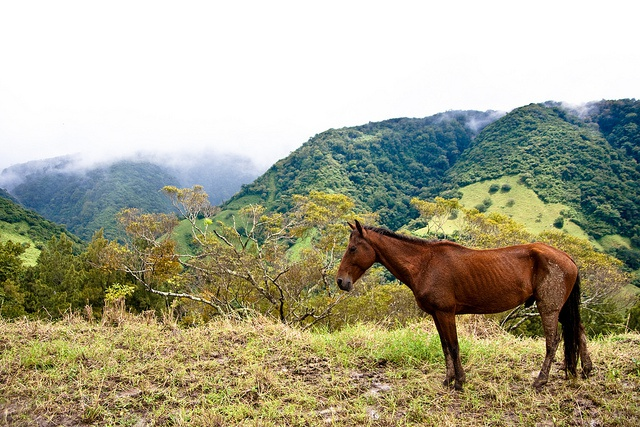Describe the objects in this image and their specific colors. I can see a horse in white, maroon, black, and brown tones in this image. 